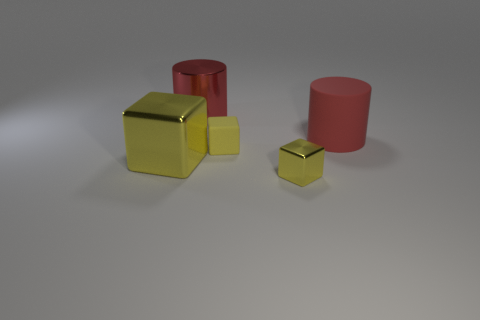Subtract all yellow blocks. How many were subtracted if there are1yellow blocks left? 2 Subtract all large blocks. How many blocks are left? 2 Subtract all cylinders. How many objects are left? 3 Add 1 small purple metallic cylinders. How many objects exist? 6 Subtract 0 blue blocks. How many objects are left? 5 Subtract all gray cubes. Subtract all yellow cylinders. How many cubes are left? 3 Subtract all cylinders. Subtract all matte objects. How many objects are left? 1 Add 1 small yellow matte cubes. How many small yellow matte cubes are left? 2 Add 3 large yellow blocks. How many large yellow blocks exist? 4 